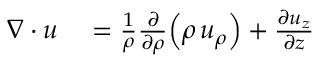Convert formula to latex. <formula><loc_0><loc_0><loc_500><loc_500>\begin{array} { r l } { \nabla \cdot { u } } & = { \frac { 1 } { \rho } } { \frac { \partial } { \partial \rho } } { \left ( } \rho \, u _ { \rho } { \right ) } + { \frac { \partial u _ { z } } { \partial z } } } \end{array}</formula> 